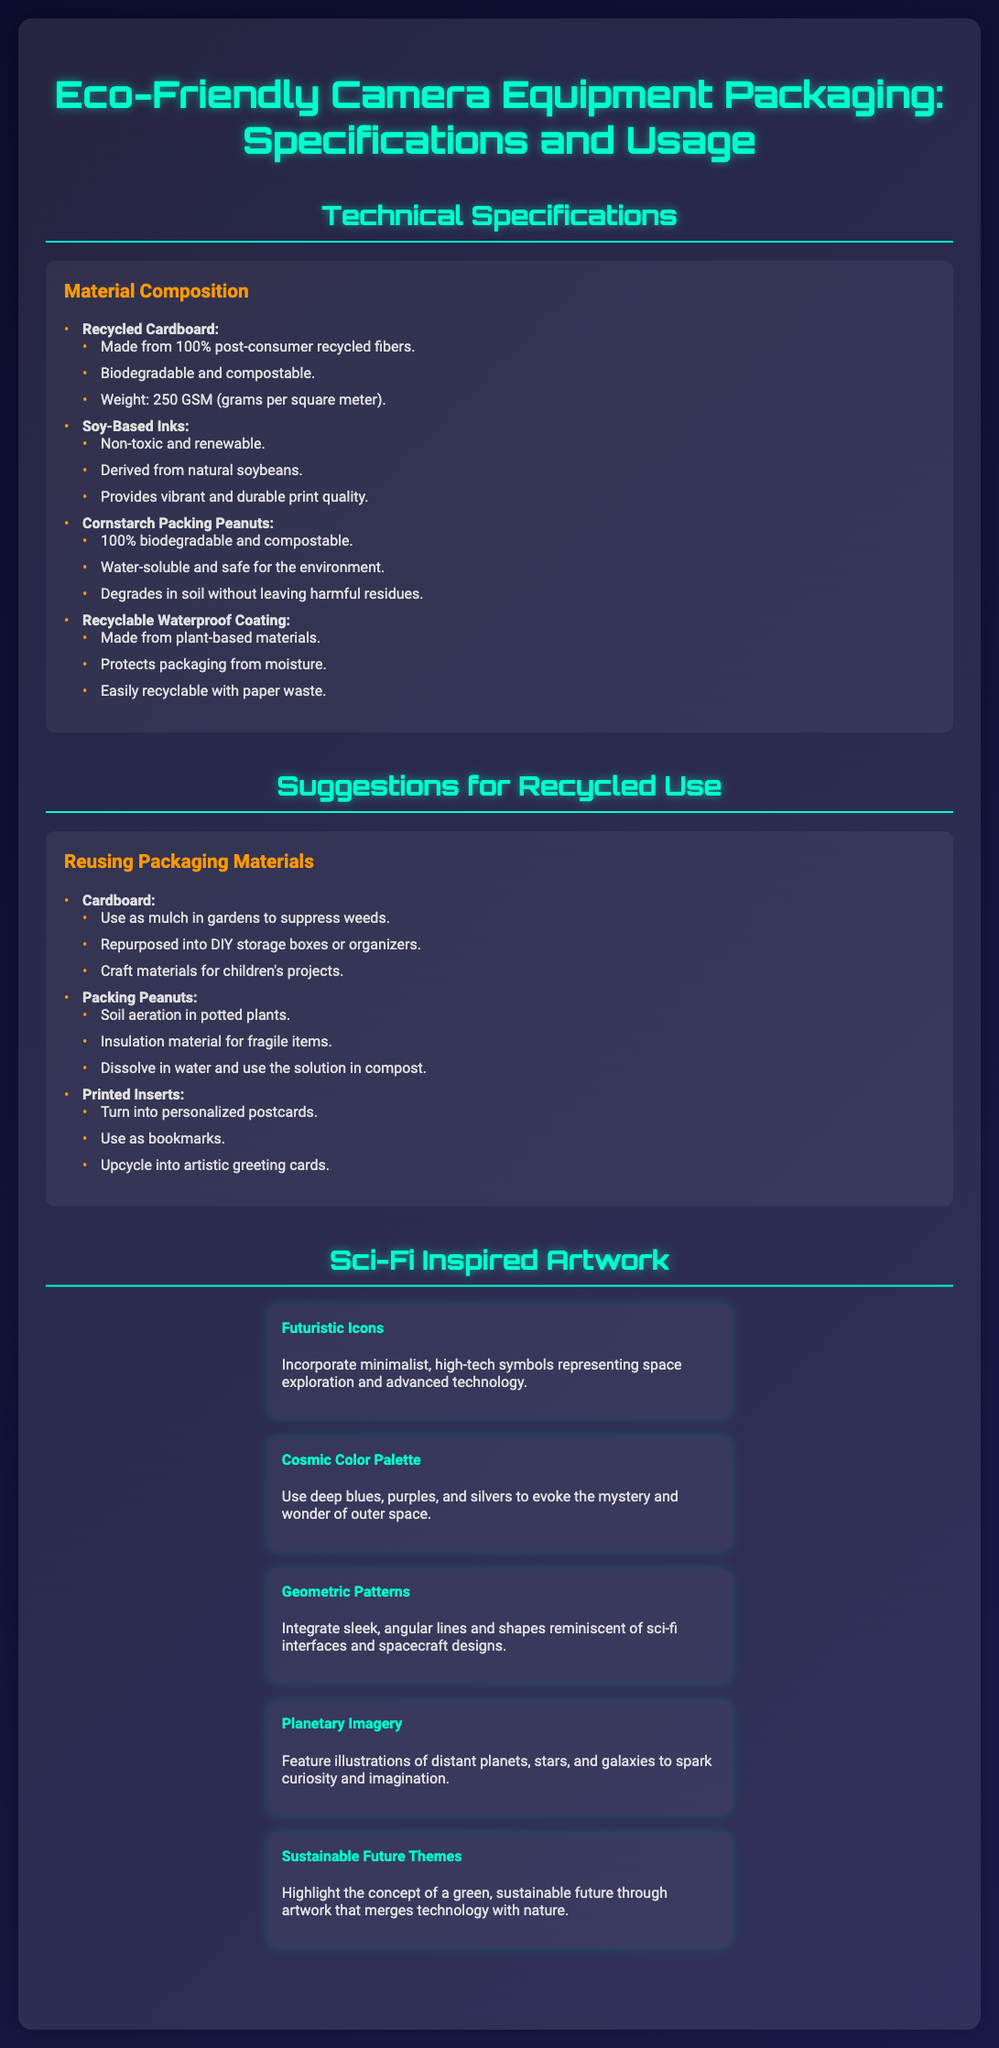what is the weight of the recycled cardboard? The weight of the recycled cardboard is specified as 250 grams per square meter.
Answer: 250 GSM what type of inks are used in the packaging? The inks used in the packaging are soy-based inks, which are non-toxic and renewable.
Answer: Soy-Based Inks how can cardboard be reused? Cardboard can be reused in several ways, such as using it as mulch in gardens or making DIY storage boxes.
Answer: Mulch in gardens what is the composition of the cornstarch packing peanuts? The cornstarch packing peanuts are specified to be 100% biodegradable and compostable.
Answer: 100% biodegradable which color palette is suggested for sci-fi artwork? The suggested color palette for sci-fi artwork includes deep blues, purples, and silvers.
Answer: Cosmic Color Palette what type of coating is used on the packaging? The type of coating used on the packaging is a recyclable waterproof coating made from plant-based materials.
Answer: Recyclable Waterproof Coating how many suggestions for recycled use are listed? There are three suggestions listed for recycled use of packaging materials.
Answer: Three what is a suggested use for packing peanuts? A suggested use for packing peanuts is as soil aeration in potted plants.
Answer: Soil aeration which theme is highlighted in the sci-fi artwork section? The theme highlighted in the sci-fi artwork section is the concept of a sustainable future.
Answer: Sustainable Future Themes 